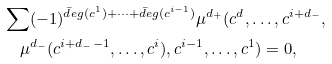<formula> <loc_0><loc_0><loc_500><loc_500>& \sum ( - 1 ) ^ { \bar { d } e g ( c ^ { 1 } ) + \cdots + \bar { d } e g ( c ^ { i - 1 } ) } \mu ^ { d _ { + } } ( c ^ { d } , \dots , c ^ { i + d _ { - } } , \\ & \quad \mu ^ { d _ { - } } ( c ^ { i + d _ { - } - 1 } , \dots , c ^ { i } ) , c ^ { i - 1 } , \dots , c ^ { 1 } ) = 0 ,</formula> 